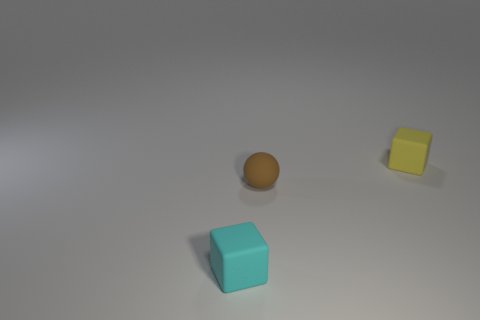The brown rubber thing is what size?
Offer a terse response. Small. How many cyan objects are tiny rubber things or rubber cubes?
Provide a short and direct response. 1. What number of cyan rubber objects are the same shape as the tiny yellow matte object?
Ensure brevity in your answer.  1. How many yellow rubber blocks are the same size as the cyan matte thing?
Give a very brief answer. 1. There is a tiny yellow object that is the same shape as the tiny cyan object; what material is it?
Make the answer very short. Rubber. The cube that is left of the small yellow block is what color?
Keep it short and to the point. Cyan. Is the number of tiny matte cubes in front of the rubber sphere greater than the number of big gray metal cylinders?
Ensure brevity in your answer.  Yes. The ball has what color?
Your answer should be very brief. Brown. There is a brown rubber object that is on the left side of the small cube behind the small block that is in front of the tiny yellow rubber block; what shape is it?
Your response must be concise. Sphere. What material is the object that is in front of the small yellow object and behind the small cyan matte object?
Your answer should be very brief. Rubber. 